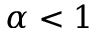<formula> <loc_0><loc_0><loc_500><loc_500>\alpha < 1</formula> 